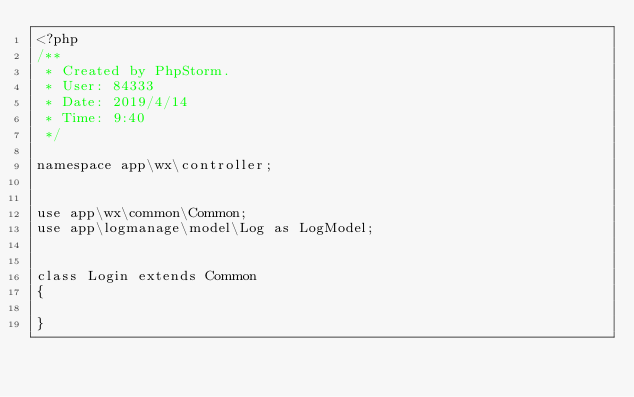<code> <loc_0><loc_0><loc_500><loc_500><_PHP_><?php
/**
 * Created by PhpStorm.
 * User: 84333
 * Date: 2019/4/14
 * Time: 9:40
 */

namespace app\wx\controller;


use app\wx\common\Common;
use app\logmanage\model\Log as LogModel;


class Login extends Common
{

}</code> 